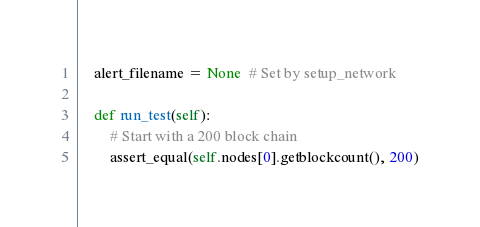Convert code to text. <code><loc_0><loc_0><loc_500><loc_500><_Python_>    alert_filename = None  # Set by setup_network

    def run_test(self):
        # Start with a 200 block chain
        assert_equal(self.nodes[0].getblockcount(), 200)
</code> 